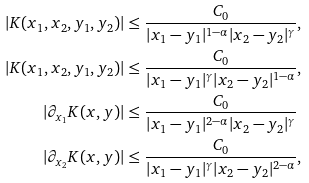<formula> <loc_0><loc_0><loc_500><loc_500>| K ( x _ { 1 } , x _ { 2 } , y _ { 1 } , y _ { 2 } ) | & \leq \frac { C _ { 0 } } { | x _ { 1 } - y _ { 1 } | ^ { 1 - \alpha } | x _ { 2 } - y _ { 2 } | ^ { \gamma } } , \\ | K ( x _ { 1 } , x _ { 2 } , y _ { 1 } , y _ { 2 } ) | & \leq \frac { C _ { 0 } } { | x _ { 1 } - y _ { 1 } | ^ { \gamma } | x _ { 2 } - y _ { 2 } | ^ { 1 - \alpha } } , \\ | \partial _ { x _ { 1 } } K ( x , y ) | & \leq \frac { C _ { 0 } } { | x _ { 1 } - y _ { 1 } | ^ { 2 - \alpha } | x _ { 2 } - y _ { 2 } | ^ { \gamma } } \\ | \partial _ { x _ { 2 } } K ( x , y ) | & \leq \frac { C _ { 0 } } { | x _ { 1 } - y _ { 1 } | ^ { \gamma } | x _ { 2 } - y _ { 2 } | ^ { 2 - \alpha } } ,</formula> 